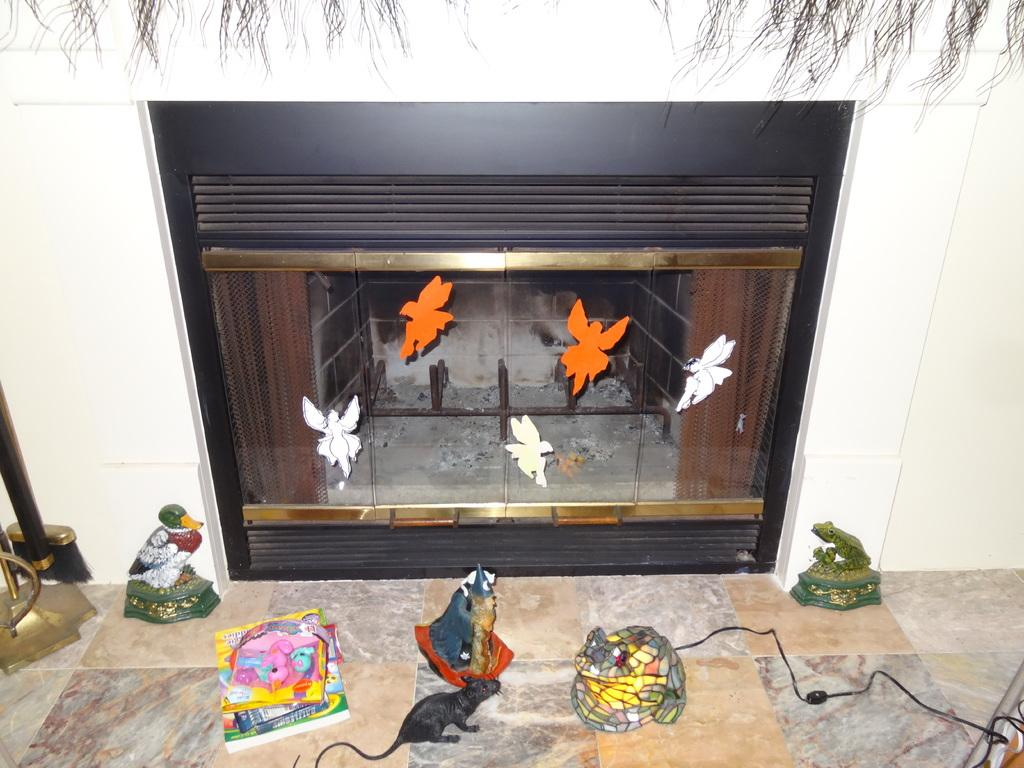What is present in the house that is visible in the image? There is a fireplace in the house. What is on the glass of the fireplace? Stickers are stuck on the glass of the fireplace. What can be seen on the floor in the image? There are toys placed on the floor. What is visible in the background of the image? There is a wall in the background of the image. How many pies are being baked in the fireplace in the image? There are no pies being baked in the fireplace in the image; it is not a cooking appliance. 